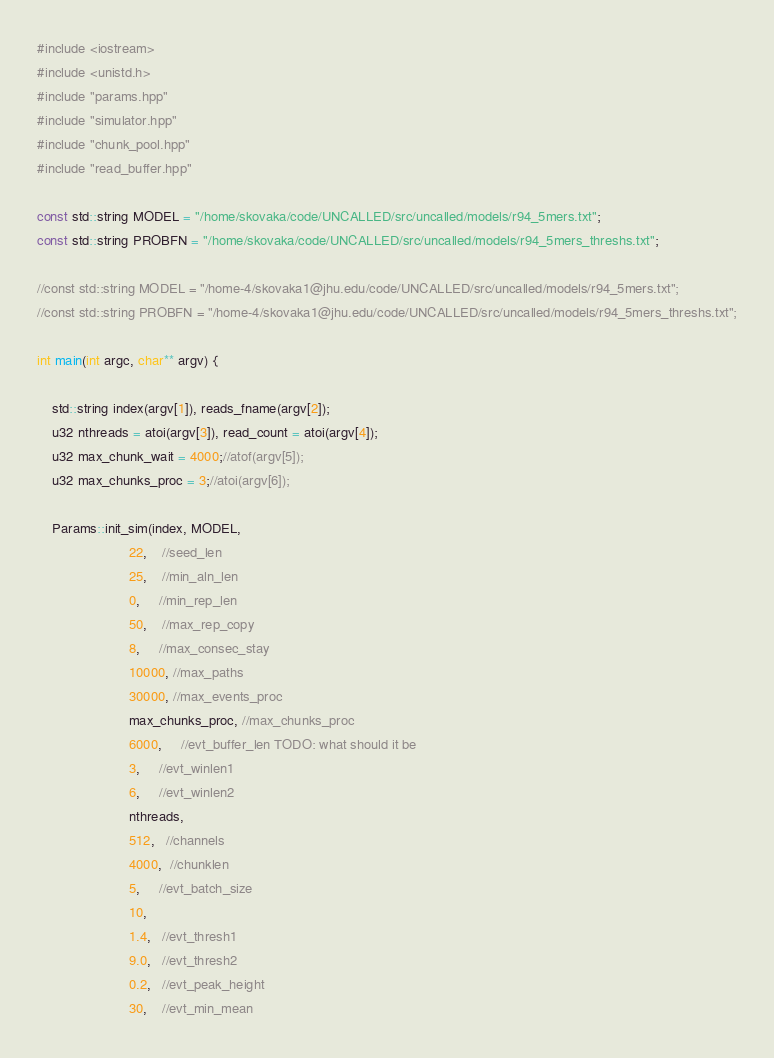<code> <loc_0><loc_0><loc_500><loc_500><_C++_>#include <iostream>
#include <unistd.h>
#include "params.hpp"
#include "simulator.hpp"
#include "chunk_pool.hpp"
#include "read_buffer.hpp"

const std::string MODEL = "/home/skovaka/code/UNCALLED/src/uncalled/models/r94_5mers.txt";
const std::string PROBFN = "/home/skovaka/code/UNCALLED/src/uncalled/models/r94_5mers_threshs.txt";

//const std::string MODEL = "/home-4/skovaka1@jhu.edu/code/UNCALLED/src/uncalled/models/r94_5mers.txt";
//const std::string PROBFN = "/home-4/skovaka1@jhu.edu/code/UNCALLED/src/uncalled/models/r94_5mers_threshs.txt";

int main(int argc, char** argv) {

    std::string index(argv[1]), reads_fname(argv[2]);
    u32 nthreads = atoi(argv[3]), read_count = atoi(argv[4]);
    u32 max_chunk_wait = 4000;//atof(argv[5]);
    u32 max_chunks_proc = 3;//atoi(argv[6]);
    
    Params::init_sim(index, MODEL,
                        22,    //seed_len
                        25,    //min_aln_len
                        0,     //min_rep_len
                        50,    //max_rep_copy
                        8,     //max_consec_stay
                        10000, //max_paths
                        30000, //max_events_proc
                        max_chunks_proc, //max_chunks_proc
                        6000,     //evt_buffer_len TODO: what should it be
                        3,     //evt_winlen1
                        6,     //evt_winlen2
                        nthreads,
                        512,   //channels
                        4000,  //chunklen
                        5,     //evt_batch_size
                        10,
                        1.4,   //evt_thresh1
                        9.0,   //evt_thresh2
                        0.2,   //evt_peak_height
                        30,    //evt_min_mean</code> 